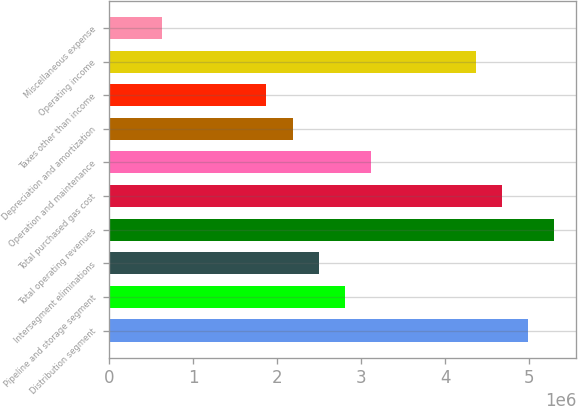Convert chart. <chart><loc_0><loc_0><loc_500><loc_500><bar_chart><fcel>Distribution segment<fcel>Pipeline and storage segment<fcel>Intersegment eliminations<fcel>Total operating revenues<fcel>Total purchased gas cost<fcel>Operation and maintenance<fcel>Depreciation and amortization<fcel>Taxes other than income<fcel>Operating income<fcel>Miscellaneous expense<nl><fcel>4.98487e+06<fcel>2.80399e+06<fcel>2.49244e+06<fcel>5.29642e+06<fcel>4.67332e+06<fcel>3.11555e+06<fcel>2.18088e+06<fcel>1.86933e+06<fcel>4.36176e+06<fcel>623114<nl></chart> 